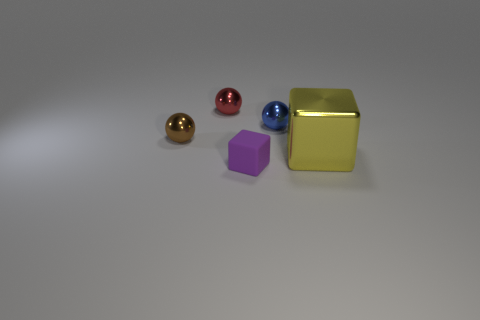Add 2 large gray rubber cylinders. How many objects exist? 7 Subtract all cubes. How many objects are left? 3 Subtract all yellow spheres. Subtract all purple cubes. How many spheres are left? 3 Add 4 small cyan shiny cylinders. How many small cyan shiny cylinders exist? 4 Subtract 0 yellow spheres. How many objects are left? 5 Subtract all blue matte spheres. Subtract all tiny red objects. How many objects are left? 4 Add 2 purple matte things. How many purple matte things are left? 3 